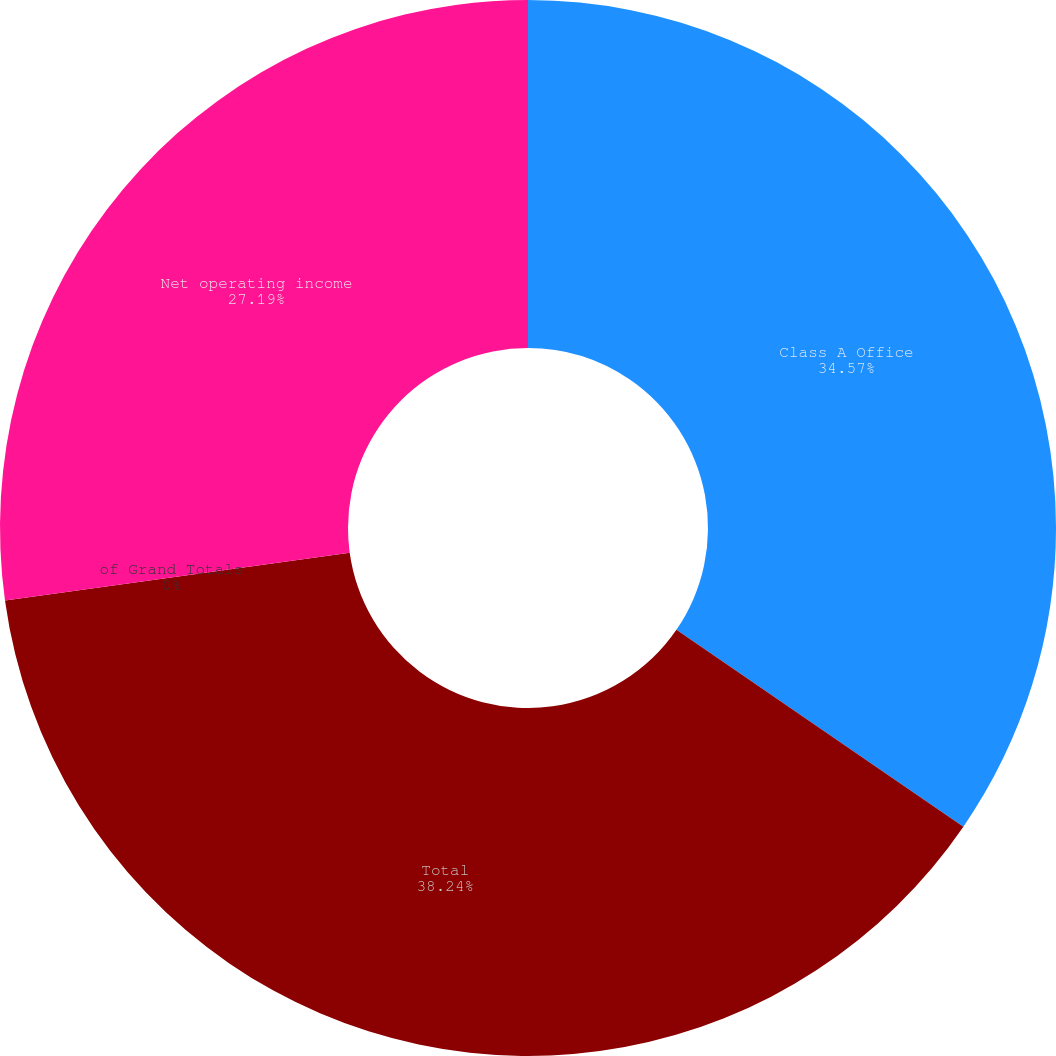Convert chart to OTSL. <chart><loc_0><loc_0><loc_500><loc_500><pie_chart><fcel>Class A Office<fcel>Total<fcel>of Grand Totals<fcel>Net operating income<nl><fcel>34.57%<fcel>38.24%<fcel>0.0%<fcel>27.19%<nl></chart> 